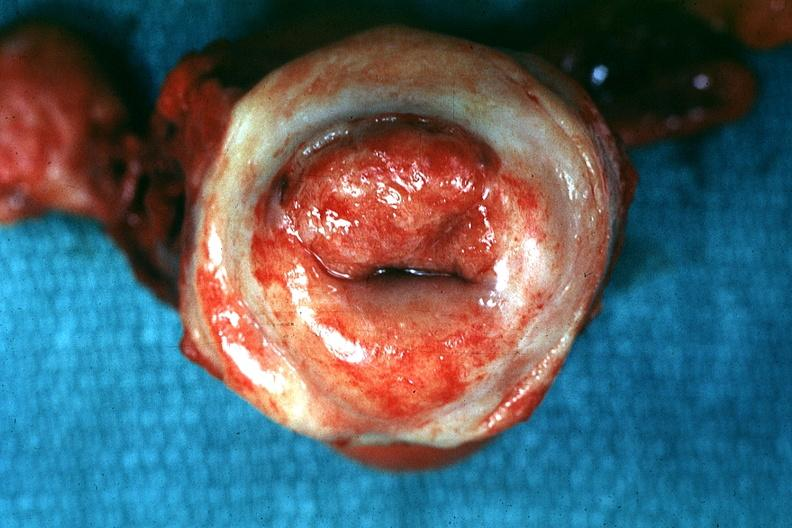how is excellent close-up of thickened and inflamed exocervix said to be carcinoma?
Answer the question using a single word or phrase. Invasive 